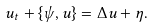Convert formula to latex. <formula><loc_0><loc_0><loc_500><loc_500>u _ { t } + \{ \psi , u \} = \Delta u + \eta .</formula> 